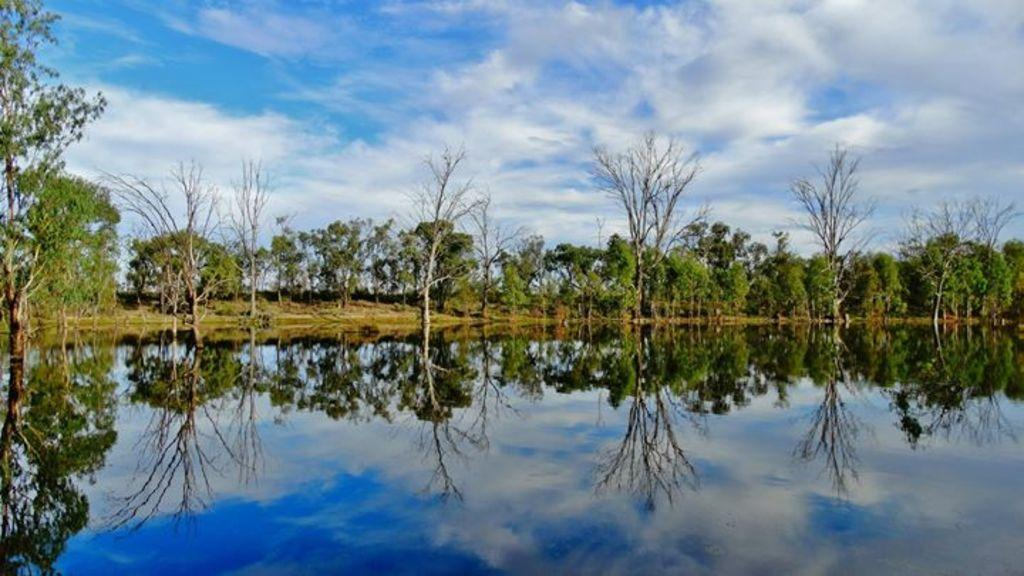What can be seen in the image? There is water visible in the image. What is present in the background of the image? There are trees in the background of the image, and the sky is sunny. How many toes can be seen in the image? There are no toes visible in the image. 